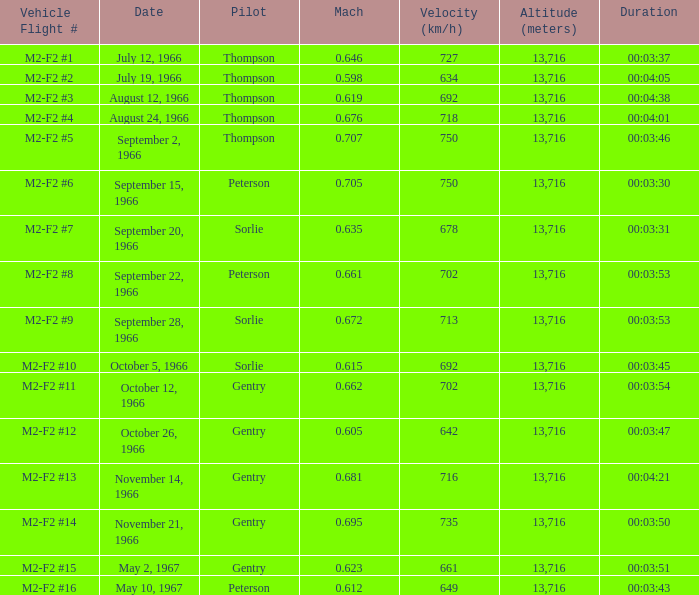What Vehicle Flight # has Pilot Peterson and Velocity (km/h) of 649? M2-F2 #16. 